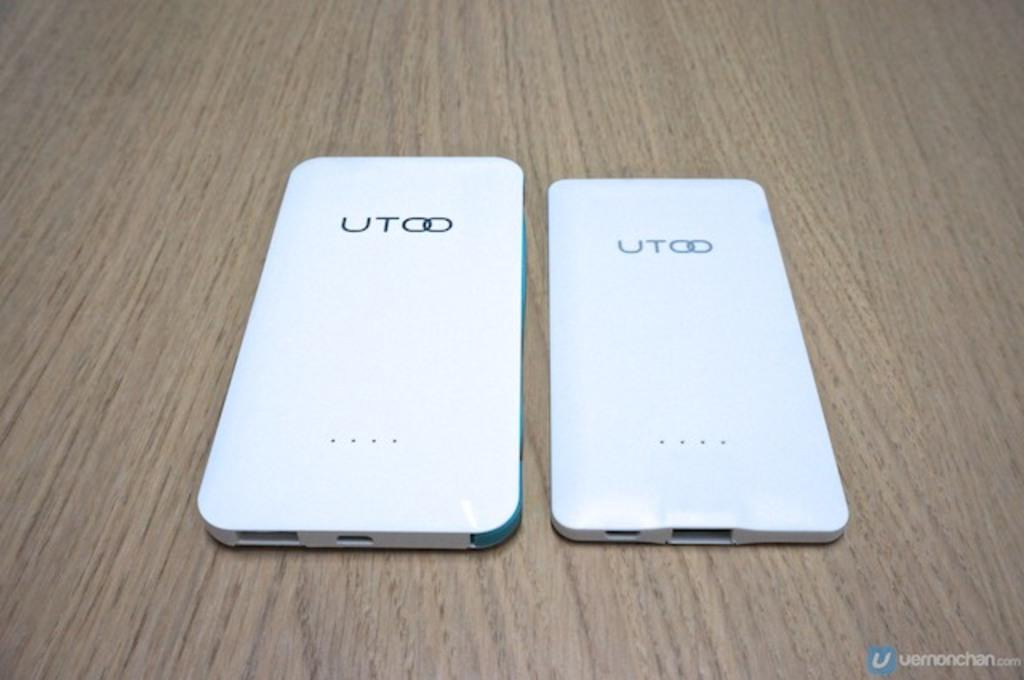How many mobile phones are visible in the image? There are two mobile phones in the image. What color are the mobile phones? The mobile phones are white in color. Where are the mobile phones located in the image? The mobile phones are on a table. What type of produce is being used to paste the club's logo on the mobile phones? There is no produce, paste, or club's logo present in the image. 